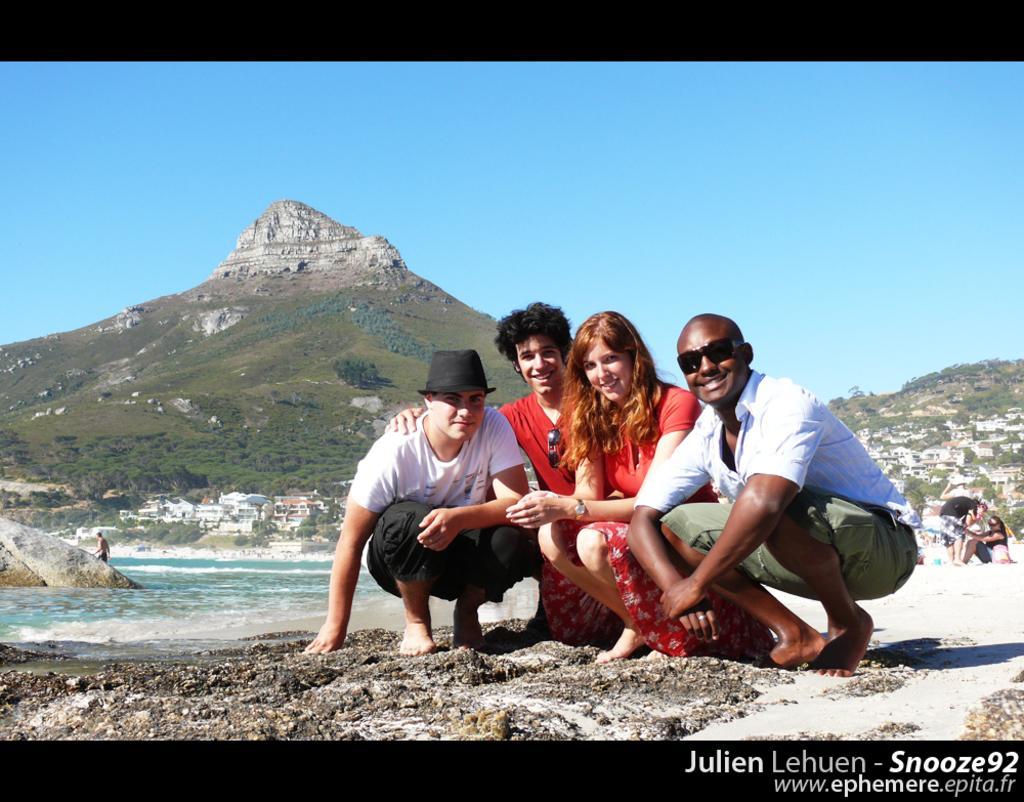Please provide a concise description of this image. In this image we can see two hills. There are many trees and plants in the image. There is a sea in the image. There are few people in the image. A person is wearing a hat in the image. There is a rock in the image. There are many houses and buildings in the image. 